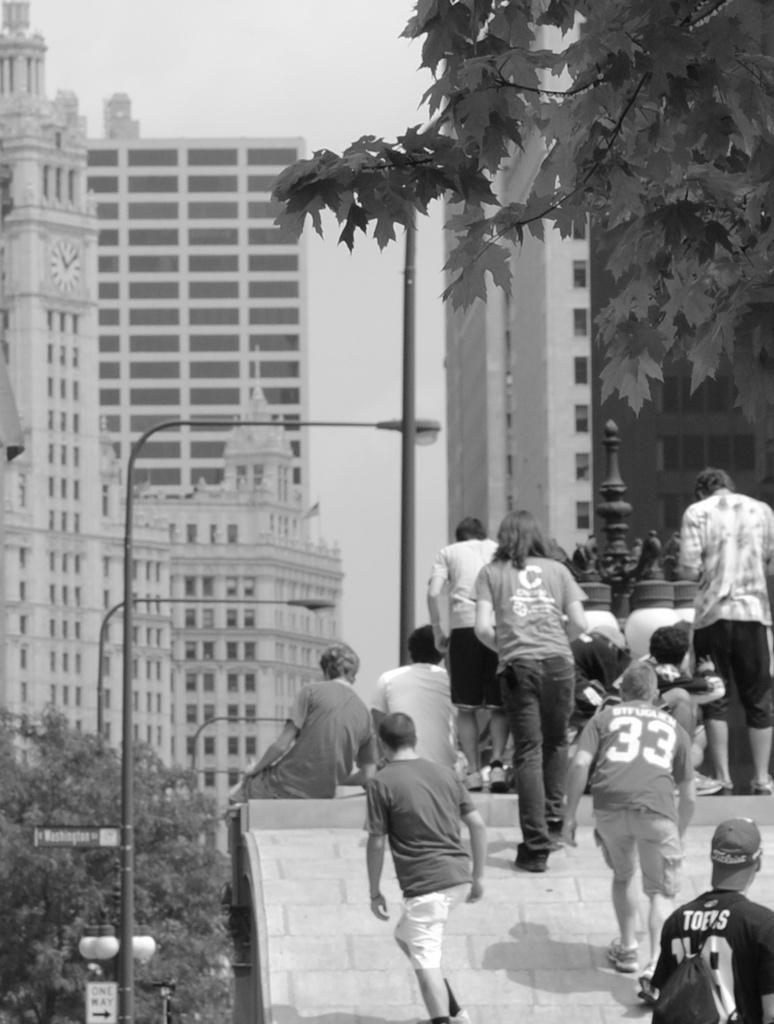<image>
Describe the image concisely. A kid with a 33 Jersey walking up a roof with other people 